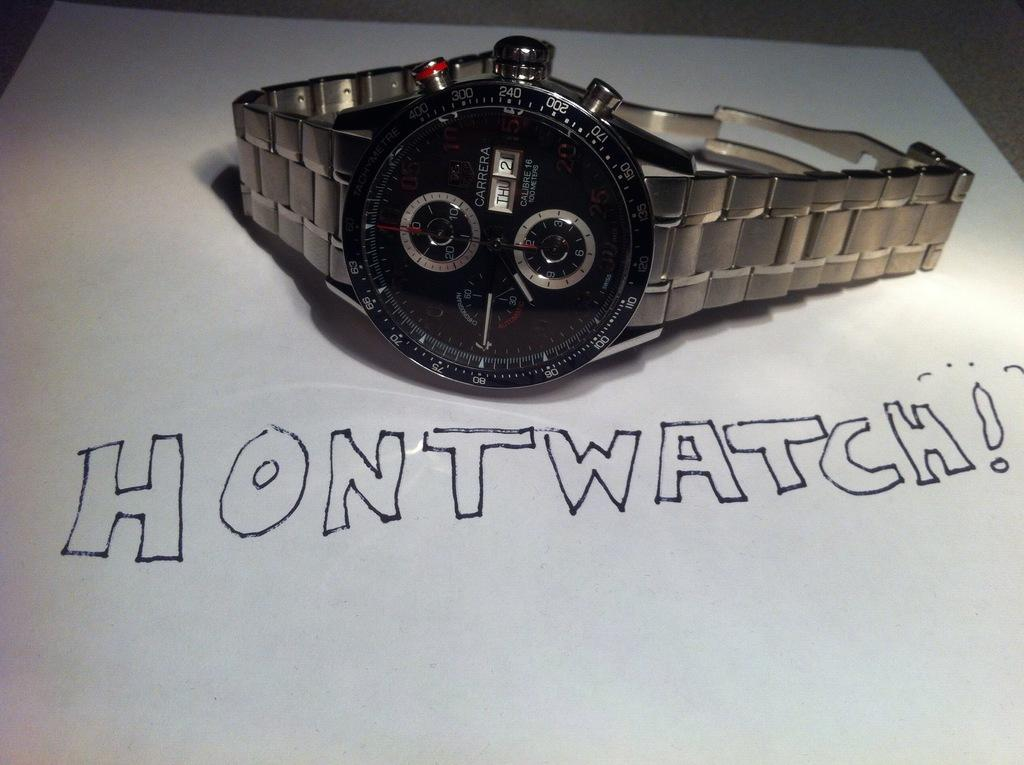<image>
Relay a brief, clear account of the picture shown. A large silver watch sits next to a handwritten note that says Hontwatch. 